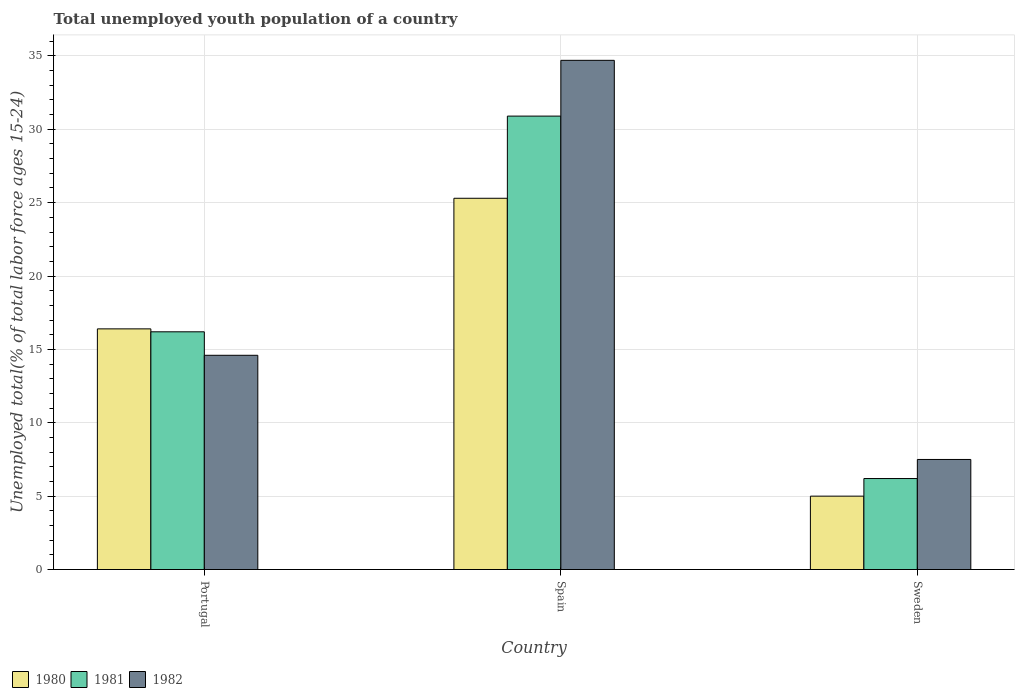How many groups of bars are there?
Provide a short and direct response. 3. Are the number of bars per tick equal to the number of legend labels?
Provide a succinct answer. Yes. Are the number of bars on each tick of the X-axis equal?
Your answer should be compact. Yes. How many bars are there on the 2nd tick from the left?
Offer a very short reply. 3. How many bars are there on the 3rd tick from the right?
Provide a succinct answer. 3. What is the label of the 1st group of bars from the left?
Give a very brief answer. Portugal. In how many cases, is the number of bars for a given country not equal to the number of legend labels?
Keep it short and to the point. 0. What is the percentage of total unemployed youth population of a country in 1982 in Sweden?
Offer a very short reply. 7.5. Across all countries, what is the maximum percentage of total unemployed youth population of a country in 1981?
Make the answer very short. 30.9. Across all countries, what is the minimum percentage of total unemployed youth population of a country in 1981?
Give a very brief answer. 6.2. In which country was the percentage of total unemployed youth population of a country in 1981 maximum?
Keep it short and to the point. Spain. In which country was the percentage of total unemployed youth population of a country in 1982 minimum?
Ensure brevity in your answer.  Sweden. What is the total percentage of total unemployed youth population of a country in 1981 in the graph?
Your response must be concise. 53.3. What is the difference between the percentage of total unemployed youth population of a country in 1980 in Spain and that in Sweden?
Give a very brief answer. 20.3. What is the difference between the percentage of total unemployed youth population of a country in 1981 in Portugal and the percentage of total unemployed youth population of a country in 1980 in Sweden?
Your answer should be compact. 11.2. What is the average percentage of total unemployed youth population of a country in 1981 per country?
Provide a succinct answer. 17.77. What is the difference between the percentage of total unemployed youth population of a country of/in 1982 and percentage of total unemployed youth population of a country of/in 1980 in Spain?
Your answer should be very brief. 9.4. What is the ratio of the percentage of total unemployed youth population of a country in 1982 in Portugal to that in Spain?
Your answer should be very brief. 0.42. Is the difference between the percentage of total unemployed youth population of a country in 1982 in Portugal and Sweden greater than the difference between the percentage of total unemployed youth population of a country in 1980 in Portugal and Sweden?
Keep it short and to the point. No. What is the difference between the highest and the second highest percentage of total unemployed youth population of a country in 1981?
Your answer should be very brief. -14.7. What is the difference between the highest and the lowest percentage of total unemployed youth population of a country in 1982?
Your answer should be very brief. 27.2. In how many countries, is the percentage of total unemployed youth population of a country in 1982 greater than the average percentage of total unemployed youth population of a country in 1982 taken over all countries?
Your answer should be very brief. 1. Is the sum of the percentage of total unemployed youth population of a country in 1982 in Spain and Sweden greater than the maximum percentage of total unemployed youth population of a country in 1980 across all countries?
Your answer should be very brief. Yes. What does the 3rd bar from the left in Spain represents?
Make the answer very short. 1982. What does the 2nd bar from the right in Sweden represents?
Ensure brevity in your answer.  1981. Is it the case that in every country, the sum of the percentage of total unemployed youth population of a country in 1980 and percentage of total unemployed youth population of a country in 1982 is greater than the percentage of total unemployed youth population of a country in 1981?
Your answer should be very brief. Yes. How many bars are there?
Your answer should be very brief. 9. What is the difference between two consecutive major ticks on the Y-axis?
Provide a succinct answer. 5. Does the graph contain any zero values?
Keep it short and to the point. No. Where does the legend appear in the graph?
Your response must be concise. Bottom left. How many legend labels are there?
Offer a terse response. 3. What is the title of the graph?
Your response must be concise. Total unemployed youth population of a country. What is the label or title of the X-axis?
Offer a terse response. Country. What is the label or title of the Y-axis?
Provide a succinct answer. Unemployed total(% of total labor force ages 15-24). What is the Unemployed total(% of total labor force ages 15-24) in 1980 in Portugal?
Your answer should be very brief. 16.4. What is the Unemployed total(% of total labor force ages 15-24) in 1981 in Portugal?
Keep it short and to the point. 16.2. What is the Unemployed total(% of total labor force ages 15-24) in 1982 in Portugal?
Provide a short and direct response. 14.6. What is the Unemployed total(% of total labor force ages 15-24) of 1980 in Spain?
Give a very brief answer. 25.3. What is the Unemployed total(% of total labor force ages 15-24) of 1981 in Spain?
Give a very brief answer. 30.9. What is the Unemployed total(% of total labor force ages 15-24) of 1982 in Spain?
Provide a short and direct response. 34.7. What is the Unemployed total(% of total labor force ages 15-24) of 1980 in Sweden?
Keep it short and to the point. 5. What is the Unemployed total(% of total labor force ages 15-24) in 1981 in Sweden?
Ensure brevity in your answer.  6.2. Across all countries, what is the maximum Unemployed total(% of total labor force ages 15-24) of 1980?
Make the answer very short. 25.3. Across all countries, what is the maximum Unemployed total(% of total labor force ages 15-24) of 1981?
Your response must be concise. 30.9. Across all countries, what is the maximum Unemployed total(% of total labor force ages 15-24) of 1982?
Make the answer very short. 34.7. Across all countries, what is the minimum Unemployed total(% of total labor force ages 15-24) in 1981?
Offer a terse response. 6.2. What is the total Unemployed total(% of total labor force ages 15-24) in 1980 in the graph?
Keep it short and to the point. 46.7. What is the total Unemployed total(% of total labor force ages 15-24) of 1981 in the graph?
Give a very brief answer. 53.3. What is the total Unemployed total(% of total labor force ages 15-24) in 1982 in the graph?
Offer a terse response. 56.8. What is the difference between the Unemployed total(% of total labor force ages 15-24) of 1980 in Portugal and that in Spain?
Make the answer very short. -8.9. What is the difference between the Unemployed total(% of total labor force ages 15-24) of 1981 in Portugal and that in Spain?
Keep it short and to the point. -14.7. What is the difference between the Unemployed total(% of total labor force ages 15-24) of 1982 in Portugal and that in Spain?
Offer a terse response. -20.1. What is the difference between the Unemployed total(% of total labor force ages 15-24) of 1980 in Portugal and that in Sweden?
Your response must be concise. 11.4. What is the difference between the Unemployed total(% of total labor force ages 15-24) of 1981 in Portugal and that in Sweden?
Your response must be concise. 10. What is the difference between the Unemployed total(% of total labor force ages 15-24) of 1982 in Portugal and that in Sweden?
Keep it short and to the point. 7.1. What is the difference between the Unemployed total(% of total labor force ages 15-24) of 1980 in Spain and that in Sweden?
Your response must be concise. 20.3. What is the difference between the Unemployed total(% of total labor force ages 15-24) in 1981 in Spain and that in Sweden?
Keep it short and to the point. 24.7. What is the difference between the Unemployed total(% of total labor force ages 15-24) of 1982 in Spain and that in Sweden?
Offer a very short reply. 27.2. What is the difference between the Unemployed total(% of total labor force ages 15-24) of 1980 in Portugal and the Unemployed total(% of total labor force ages 15-24) of 1981 in Spain?
Provide a succinct answer. -14.5. What is the difference between the Unemployed total(% of total labor force ages 15-24) of 1980 in Portugal and the Unemployed total(% of total labor force ages 15-24) of 1982 in Spain?
Offer a very short reply. -18.3. What is the difference between the Unemployed total(% of total labor force ages 15-24) of 1981 in Portugal and the Unemployed total(% of total labor force ages 15-24) of 1982 in Spain?
Ensure brevity in your answer.  -18.5. What is the difference between the Unemployed total(% of total labor force ages 15-24) of 1980 in Portugal and the Unemployed total(% of total labor force ages 15-24) of 1982 in Sweden?
Provide a succinct answer. 8.9. What is the difference between the Unemployed total(% of total labor force ages 15-24) of 1980 in Spain and the Unemployed total(% of total labor force ages 15-24) of 1981 in Sweden?
Offer a terse response. 19.1. What is the difference between the Unemployed total(% of total labor force ages 15-24) in 1981 in Spain and the Unemployed total(% of total labor force ages 15-24) in 1982 in Sweden?
Provide a succinct answer. 23.4. What is the average Unemployed total(% of total labor force ages 15-24) in 1980 per country?
Keep it short and to the point. 15.57. What is the average Unemployed total(% of total labor force ages 15-24) in 1981 per country?
Give a very brief answer. 17.77. What is the average Unemployed total(% of total labor force ages 15-24) in 1982 per country?
Make the answer very short. 18.93. What is the difference between the Unemployed total(% of total labor force ages 15-24) in 1980 and Unemployed total(% of total labor force ages 15-24) in 1981 in Portugal?
Make the answer very short. 0.2. What is the difference between the Unemployed total(% of total labor force ages 15-24) in 1980 and Unemployed total(% of total labor force ages 15-24) in 1982 in Portugal?
Give a very brief answer. 1.8. What is the difference between the Unemployed total(% of total labor force ages 15-24) in 1980 and Unemployed total(% of total labor force ages 15-24) in 1981 in Sweden?
Give a very brief answer. -1.2. What is the difference between the Unemployed total(% of total labor force ages 15-24) of 1980 and Unemployed total(% of total labor force ages 15-24) of 1982 in Sweden?
Provide a short and direct response. -2.5. What is the difference between the Unemployed total(% of total labor force ages 15-24) in 1981 and Unemployed total(% of total labor force ages 15-24) in 1982 in Sweden?
Offer a very short reply. -1.3. What is the ratio of the Unemployed total(% of total labor force ages 15-24) of 1980 in Portugal to that in Spain?
Keep it short and to the point. 0.65. What is the ratio of the Unemployed total(% of total labor force ages 15-24) in 1981 in Portugal to that in Spain?
Offer a very short reply. 0.52. What is the ratio of the Unemployed total(% of total labor force ages 15-24) in 1982 in Portugal to that in Spain?
Offer a terse response. 0.42. What is the ratio of the Unemployed total(% of total labor force ages 15-24) of 1980 in Portugal to that in Sweden?
Offer a very short reply. 3.28. What is the ratio of the Unemployed total(% of total labor force ages 15-24) of 1981 in Portugal to that in Sweden?
Offer a terse response. 2.61. What is the ratio of the Unemployed total(% of total labor force ages 15-24) in 1982 in Portugal to that in Sweden?
Provide a short and direct response. 1.95. What is the ratio of the Unemployed total(% of total labor force ages 15-24) in 1980 in Spain to that in Sweden?
Provide a succinct answer. 5.06. What is the ratio of the Unemployed total(% of total labor force ages 15-24) in 1981 in Spain to that in Sweden?
Offer a very short reply. 4.98. What is the ratio of the Unemployed total(% of total labor force ages 15-24) of 1982 in Spain to that in Sweden?
Ensure brevity in your answer.  4.63. What is the difference between the highest and the second highest Unemployed total(% of total labor force ages 15-24) in 1982?
Your answer should be very brief. 20.1. What is the difference between the highest and the lowest Unemployed total(% of total labor force ages 15-24) of 1980?
Provide a short and direct response. 20.3. What is the difference between the highest and the lowest Unemployed total(% of total labor force ages 15-24) of 1981?
Offer a very short reply. 24.7. What is the difference between the highest and the lowest Unemployed total(% of total labor force ages 15-24) in 1982?
Keep it short and to the point. 27.2. 